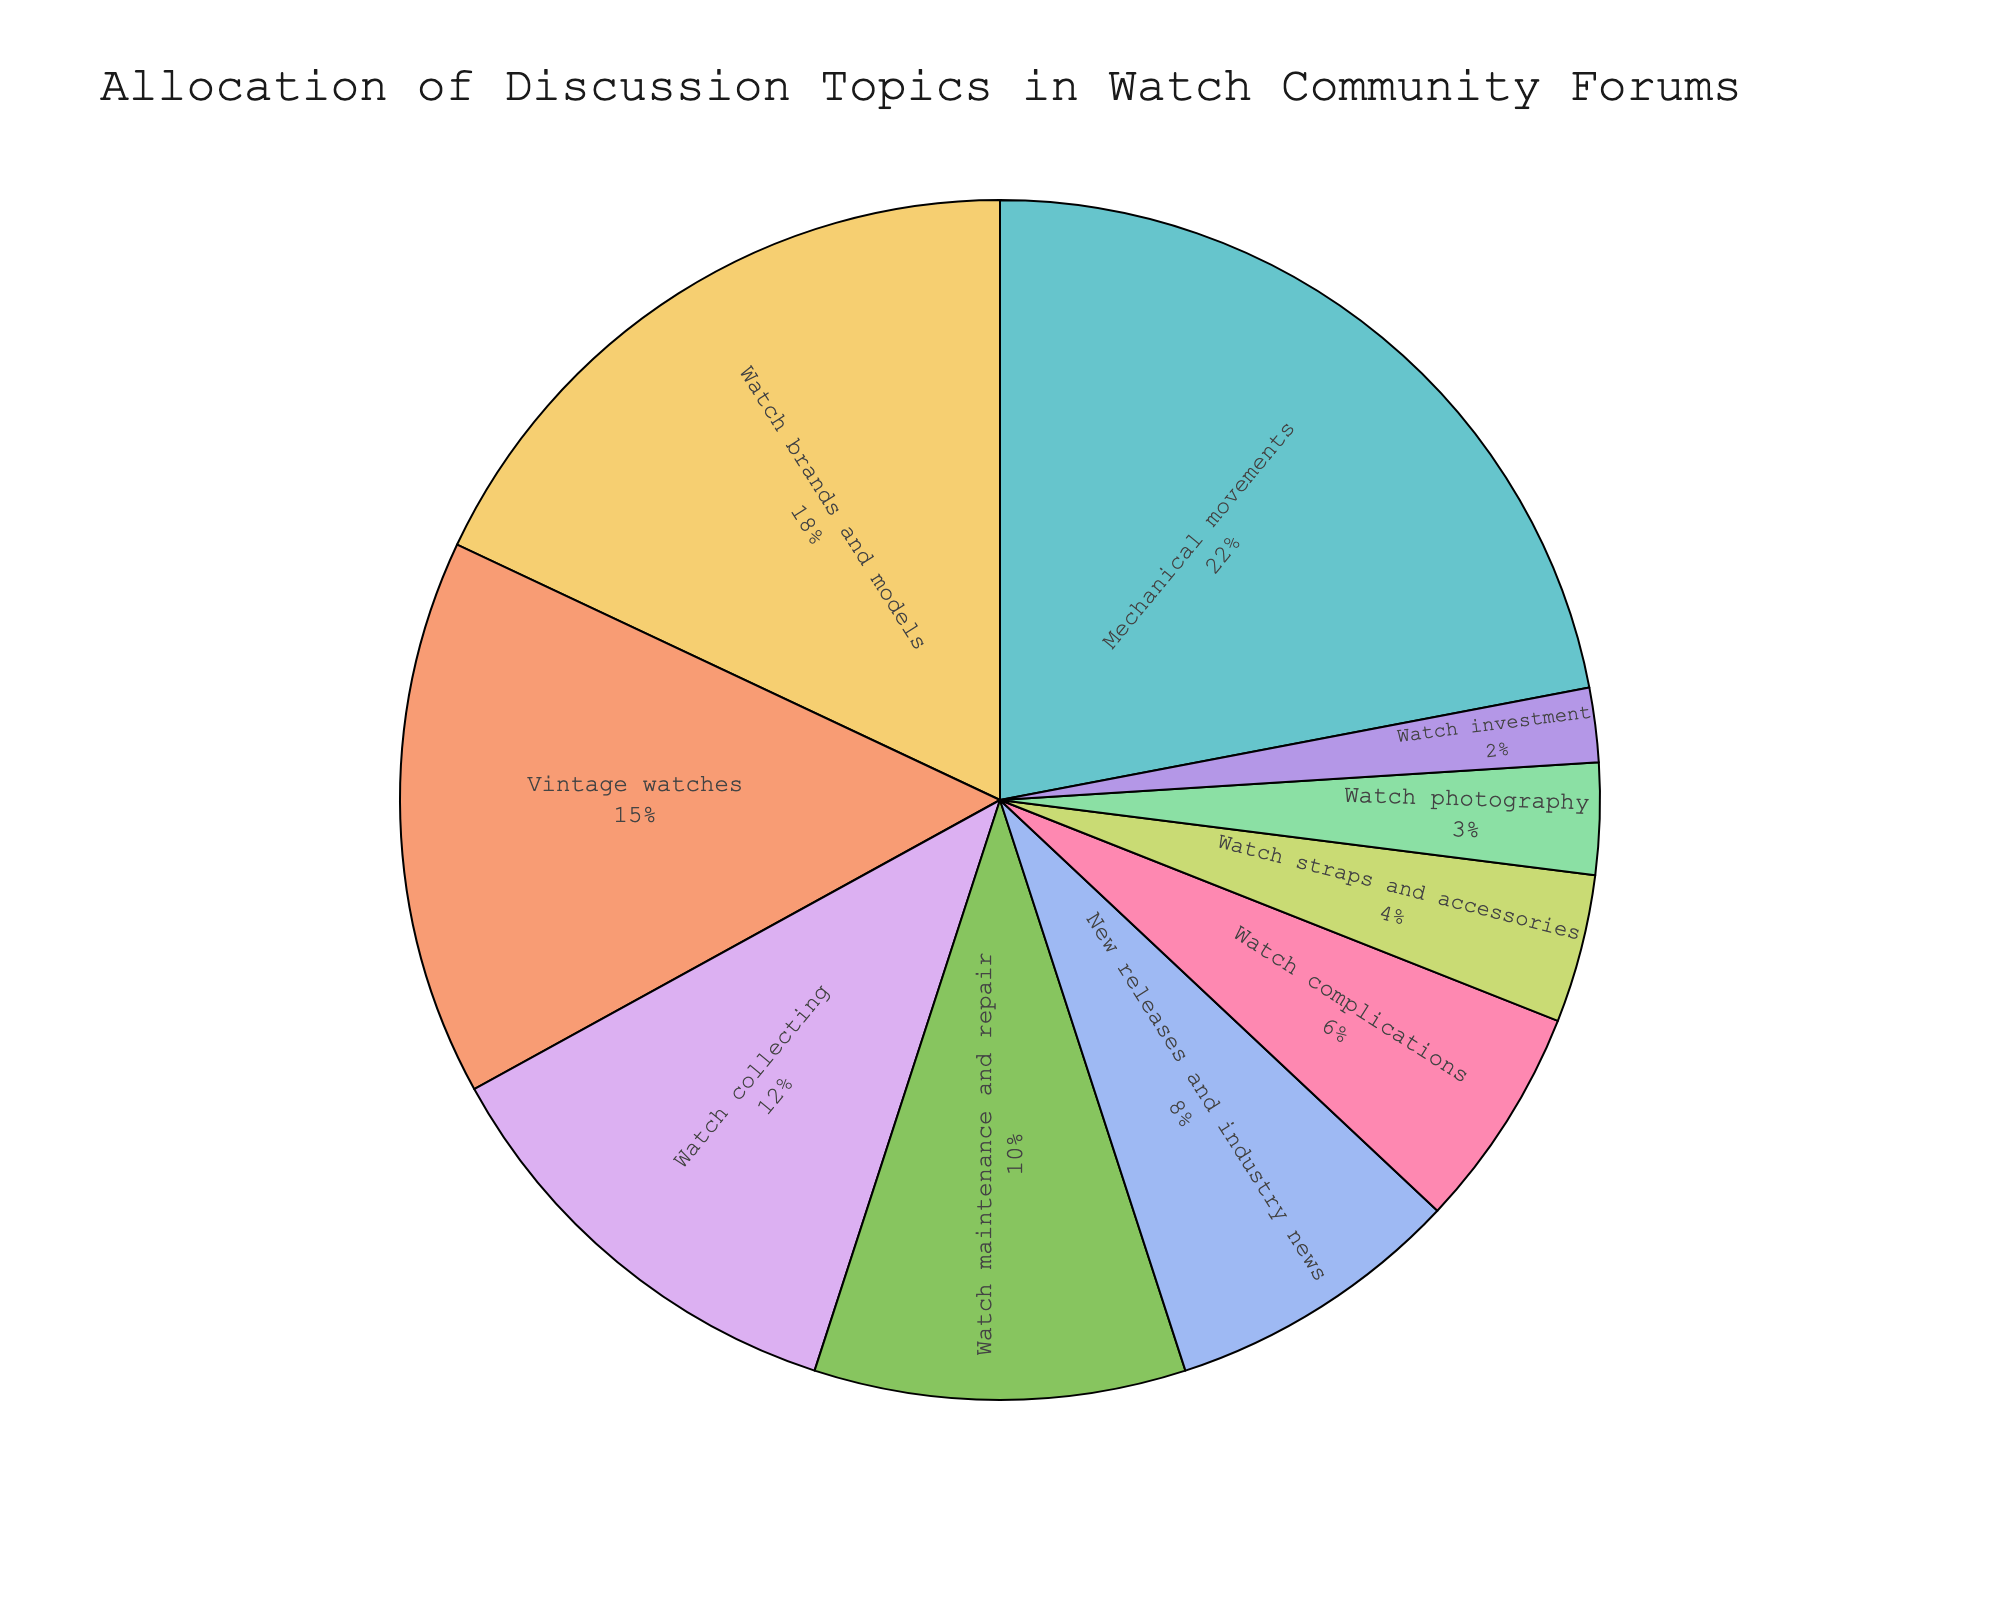What topic has the highest percentage in the allocation of discussion topics in the community forums? To answer this, look for the largest slice in the pie chart. The topic with the highest percentage will be mentioned on that slice.
Answer: Mechanical movements Which topics together account for 33% of the discussion topics in the forums? Find the segments where the percentages add up to 33%. By summing up the values, Vintage watches (15%) + New releases and industry news (8%) + Watch complications (6%) + Watch photography (3%) = 32%, thus four topics are included.
Answer: Vintage watches, New releases and industry news, Watch complications, Watch photography Which has a larger share, Watch brands and models, or Watch maintenance and repair? Compare the percentages of Watch brands and models (18%) and Watch maintenance and repair (10%). The one with the higher percentage has the larger share.
Answer: Watch brands and models If you combined the discussion percentages of Watch complications and Watch investment, what percentage do you get? Add the percentages of Watch complications (6%) and Watch investment (2%). 6% + 2% = 8%
Answer: 8% What is the visual representation color for 'Watch collecting' in the pie chart? Identify the color used for the 'Watch collecting' slice in the pie chart and mention the specific color visible.
Answer: (Specify color from visual) Are discussions on 'New releases and industry news' more frequent than 'Watch photography'? Compare the percentages of New releases and industry news (8%) and Watch photography (3%). Check which one is higher.
Answer: Yes Which topic appears to have the smallest allocation of discussion? Look for the smallest slice in the pie chart which represents the topic with the smallest percentage.
Answer: Watch investment What is the combined percentage of 'Mechanical movements' and 'Vintage watches'? Add the percentages of Mechanical movements (22%) and Vintage watches (15%). 22% + 15% = 37%
Answer: 37% How many topics have a representation of 10% or higher in the forum discussions? Count the number of slices in the pie chart that show 10% or more in their percentage label.
Answer: Four Between 'Watch straps and accessories' and 'Watch complications', which one has a lower allocation, and by how much? Compare their percentages: Watch straps and accessories (4%) and Watch complications (6%). Subtract the smaller percentage from the larger one. 6% - 4% = 2%
Answer: Watch straps and accessories, by 2% 